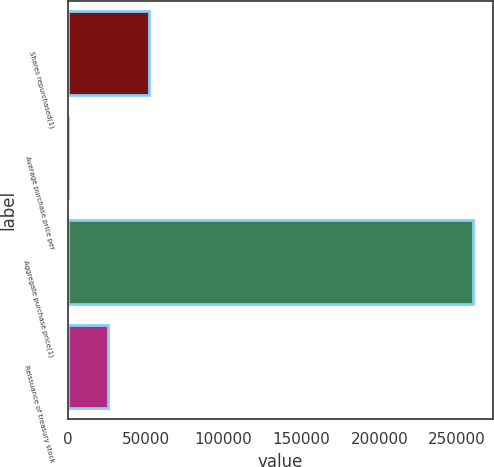<chart> <loc_0><loc_0><loc_500><loc_500><bar_chart><fcel>Shares repurchased(1)<fcel>Average purchase price per<fcel>Aggregate purchase price(1)<fcel>Reissuance of treasury stock<nl><fcel>52036.7<fcel>45.84<fcel>260000<fcel>26041.3<nl></chart> 